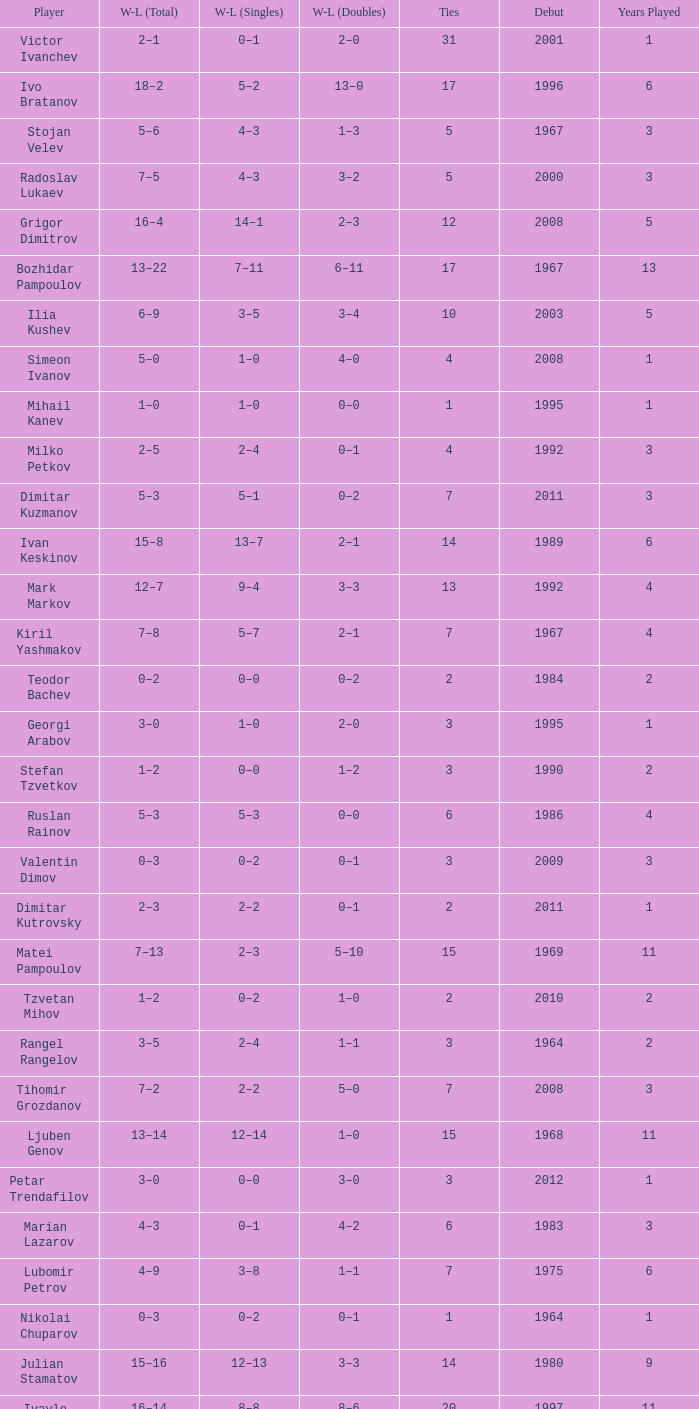Tell me the WL doubles with a debut of 1999 11–6. 